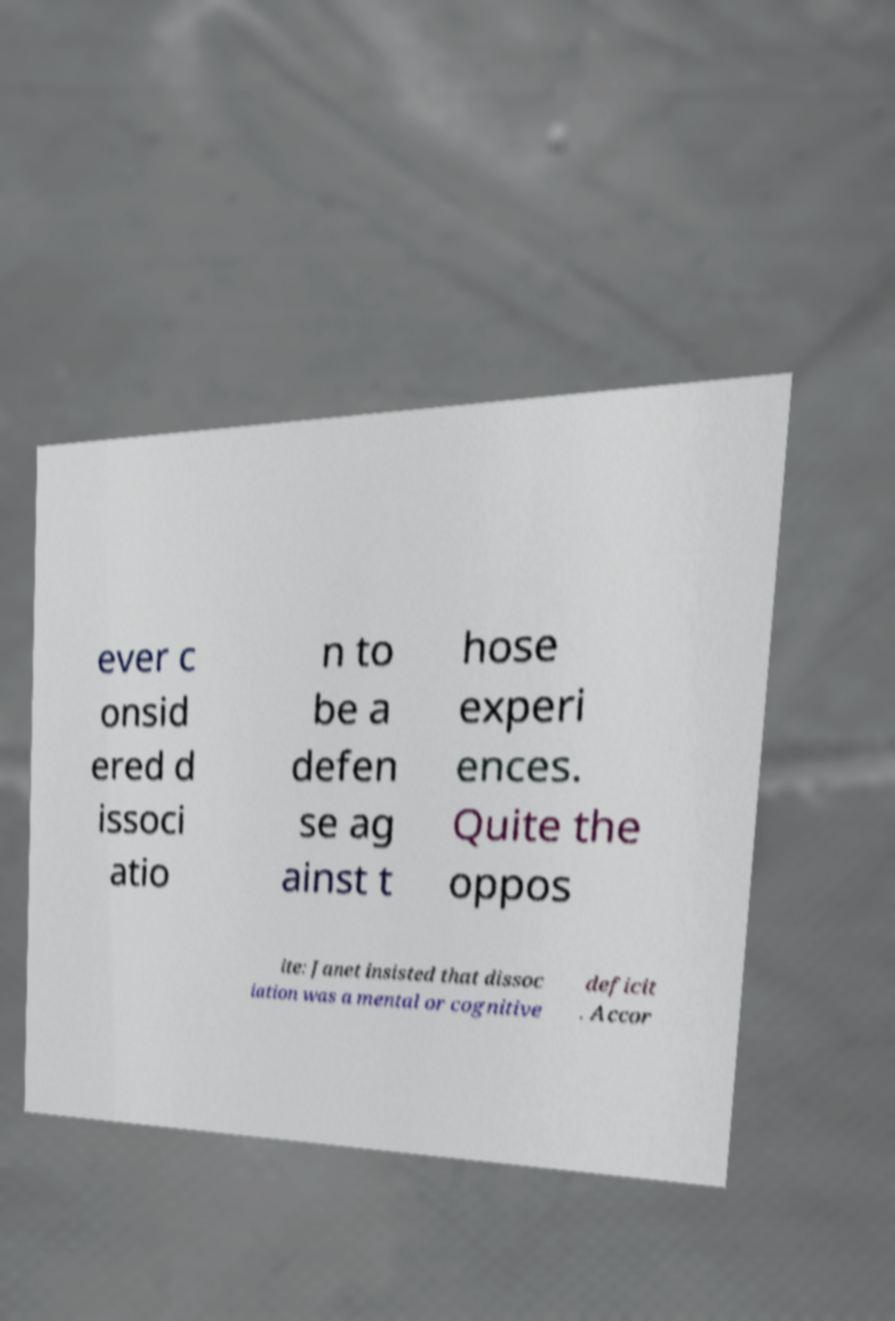Can you read and provide the text displayed in the image?This photo seems to have some interesting text. Can you extract and type it out for me? ever c onsid ered d issoci atio n to be a defen se ag ainst t hose experi ences. Quite the oppos ite: Janet insisted that dissoc iation was a mental or cognitive deficit . Accor 